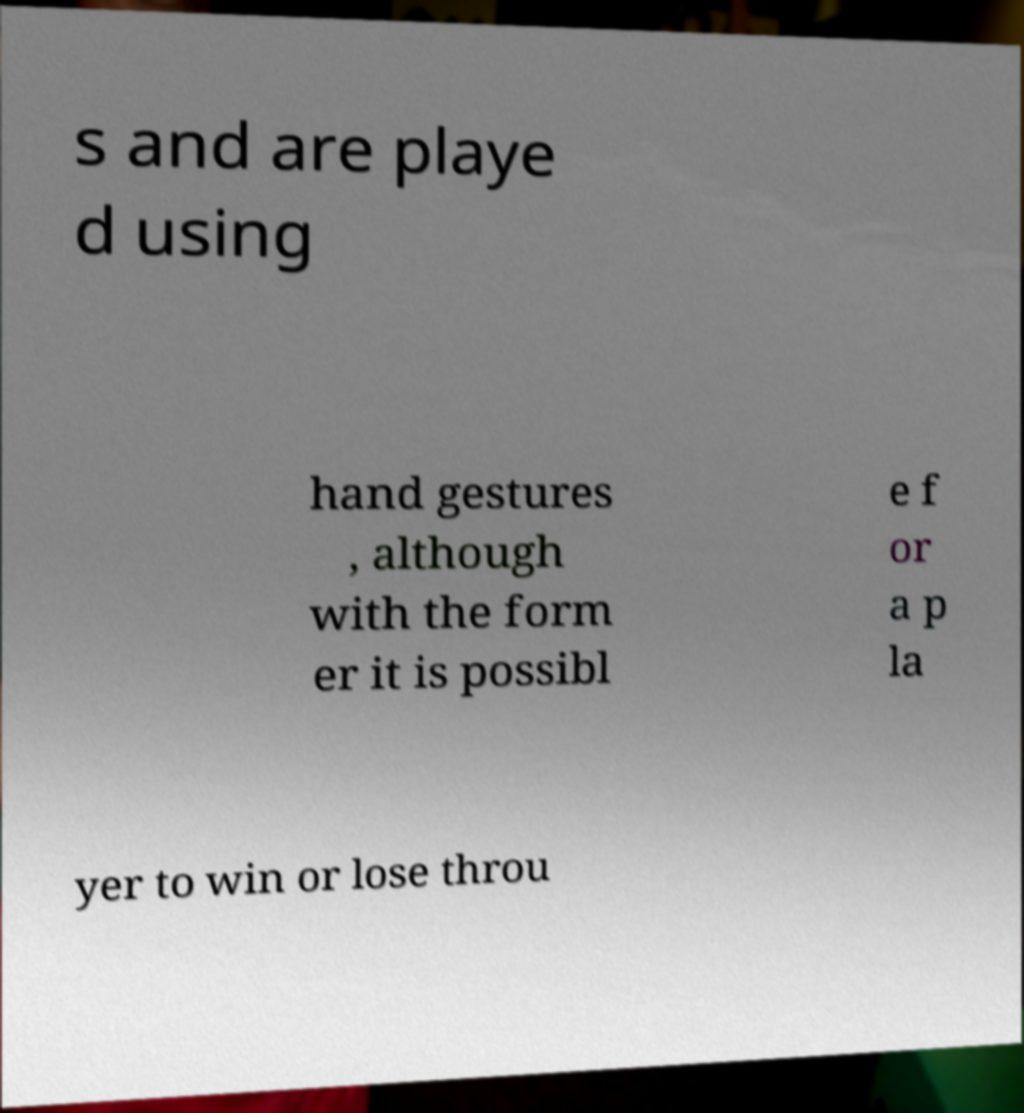Could you extract and type out the text from this image? s and are playe d using hand gestures , although with the form er it is possibl e f or a p la yer to win or lose throu 